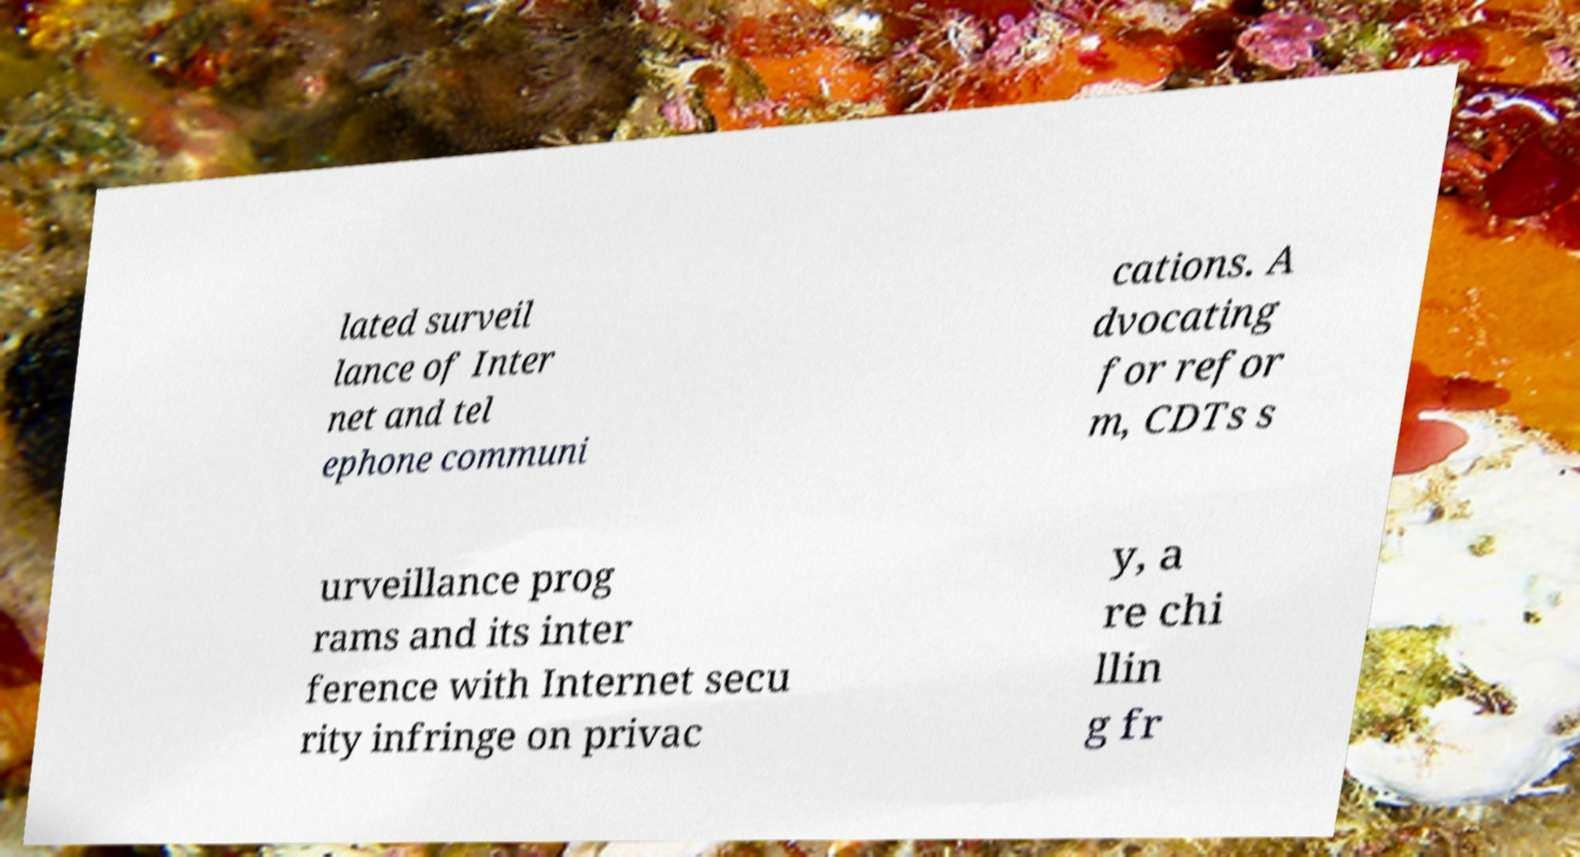Please identify and transcribe the text found in this image. lated surveil lance of Inter net and tel ephone communi cations. A dvocating for refor m, CDTs s urveillance prog rams and its inter ference with Internet secu rity infringe on privac y, a re chi llin g fr 